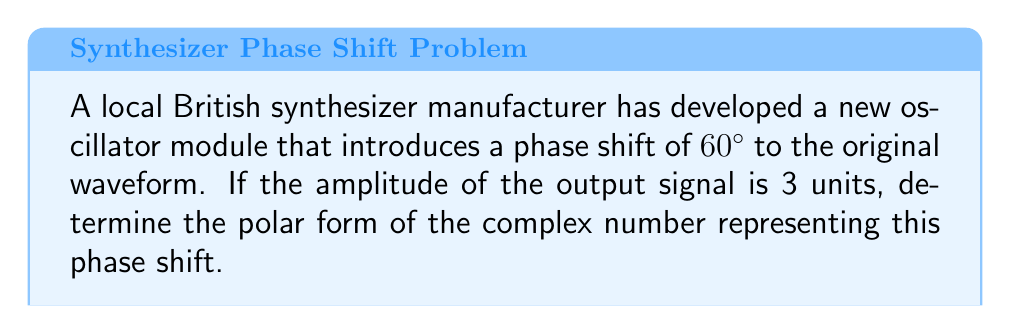Help me with this question. To solve this problem, we need to follow these steps:

1) First, recall that the polar form of a complex number is given by:

   $$r(\cos\theta + i\sin\theta)$$

   where $r$ is the magnitude (or modulus) and $\theta$ is the argument (or angle) in radians.

2) In this case, we are given:
   - Amplitude (magnitude) = 3 units
   - Phase shift = 60°

3) The magnitude $r$ is straightforward: it's the amplitude, which is 3.

4) For the angle, we need to convert 60° to radians:

   $$\theta = 60° \cdot \frac{\pi}{180°} = \frac{\pi}{3} \text{ radians}$$

5) Now we can write our complex number in polar form:

   $$3(\cos\frac{\pi}{3} + i\sin\frac{\pi}{3})$$

6) We could leave it in this form, but let's evaluate the trigonometric functions for completeness:

   $$\cos\frac{\pi}{3} = \frac{1}{2}$$
   $$\sin\frac{\pi}{3} = \frac{\sqrt{3}}{2}$$

7) Substituting these values:

   $$3(\frac{1}{2} + i\frac{\sqrt{3}}{2})$$

8) Simplifying:

   $$\frac{3}{2} + i\frac{3\sqrt{3}}{2}$$

This is the rectangular form of the complex number. The polar form is what we found in step 5.
Answer: The polar form of the complex number representing the phase shift is:

$$3(\cos\frac{\pi}{3} + i\sin\frac{\pi}{3})$$

or equivalently,

$$3e^{i\pi/3}$$ 